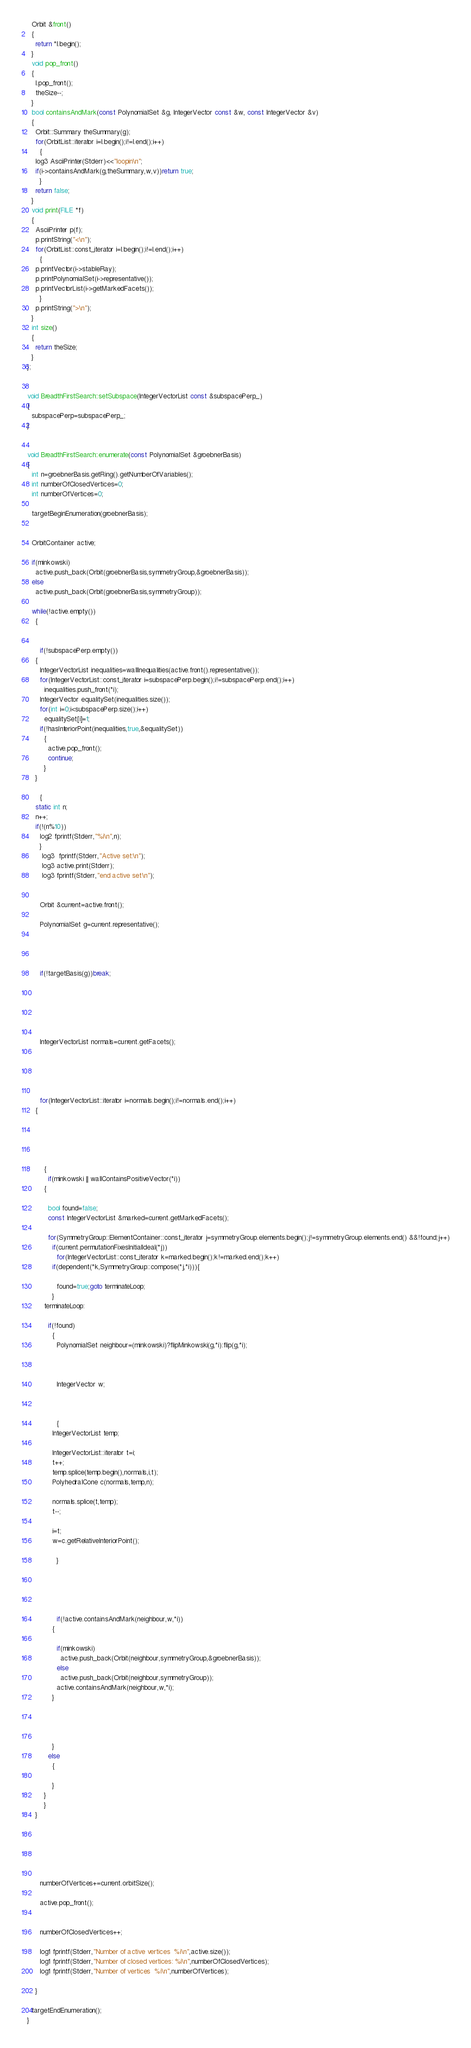<code> <loc_0><loc_0><loc_500><loc_500><_C++_>  Orbit &front()
  {
    return *l.begin();
  }
  void pop_front()
  {
    l.pop_front();
    theSize--;
  }
  bool containsAndMark(const PolynomialSet &g, IntegerVector const &w, const IntegerVector &v)
  {
    Orbit::Summary theSummary(g);
    for(OrbitList::iterator i=l.begin();i!=l.end();i++)
      {
	log3 AsciiPrinter(Stderr)<<"loopin\n";
	if(i->containsAndMark(g,theSummary,w,v))return true;
      }
    return false;
  }
  void print(FILE *f)
  {
    AsciiPrinter p(f);
    p.printString("<\n");
    for(OrbitList::const_iterator i=l.begin();i!=l.end();i++)
      {
	p.printVector(i->stableRay);
	p.printPolynomialSet(i->representative());
	p.printVectorList(i->getMarkedFacets());
      }
    p.printString(">\n");
  }
  int size()
  {    
    return theSize;
  }
};


void BreadthFirstSearch::setSubspace(IntegerVectorList const &subspacePerp_)
{
  subspacePerp=subspacePerp_;
}


void BreadthFirstSearch::enumerate(const PolynomialSet &groebnerBasis)
{
  int n=groebnerBasis.getRing().getNumberOfVariables();
  int numberOfClosedVertices=0;
  int numberOfVertices=0;

  targetBeginEnumeration(groebnerBasis);


  OrbitContainer active;

  if(minkowski)
    active.push_back(Orbit(groebnerBasis,symmetryGroup,&groebnerBasis));
  else
    active.push_back(Orbit(groebnerBasis,symmetryGroup));
    
  while(!active.empty())
    {
   

      if(!subspacePerp.empty())
	{
	  IntegerVectorList inequalities=wallInequalities(active.front().representative());
	  for(IntegerVectorList::const_iterator i=subspacePerp.begin();i!=subspacePerp.end();i++)
	    inequalities.push_front(*i);
	  IntegerVector equalitySet(inequalities.size());
	  for(int i=0;i<subspacePerp.size();i++)
	    equalitySet[i]=1;
	  if(!hasInteriorPoint(inequalities,true,&equalitySet))
	    {
	      active.pop_front();
	      continue;
	    }
	}

      {
	static int n;
	n++;
	if(!(n%10))
	  log2 fprintf(Stderr,"%i\n",n);
      }
       log3  fprintf(Stderr,"Active set:\n");
       log3 active.print(Stderr);
       log3 fprintf(Stderr,"end active set\n");
       
      
      Orbit &current=active.front();

      PolynomialSet g=current.representative();

      
      

      if(!targetBasis(g))break;

      
      

      
      
      IntegerVectorList normals=current.getFacets();

      

      

      for(IntegerVectorList::iterator i=normals.begin();i!=normals.end();i++)
	{
	  
	  
	  

	    
	    {
	      if(minkowski || wallContainsPositiveVector(*i))
		{
		  
		  bool found=false;
		  const IntegerVectorList &marked=current.getMarkedFacets();
		  
		  for(SymmetryGroup::ElementContainer::const_iterator j=symmetryGroup.elements.begin();j!=symmetryGroup.elements.end() &&!found;j++)
		    if(current.permutationFixesInitialIdeal(*j))
		      for(IntegerVectorList::const_iterator k=marked.begin();k!=marked.end();k++)
			if(dependent(*k,SymmetryGroup::compose(*j,*i))){
			  
			  found=true;goto terminateLoop;
			}
		terminateLoop:
		  
		  if(!found)
		    {
		      PolynomialSet neighbour=(minkowski)?flipMinkowski(g,*i):flip(g,*i);

		      
		      
		      IntegerVector w;

		      
		      
		      {
			IntegerVectorList temp;
			
			IntegerVectorList::iterator t=i;
			t++;
			temp.splice(temp.begin(),normals,i,t);
			PolyhedralCone c(normals,temp,n);
			
			normals.splice(t,temp);
			t--;
			
			i=t;
			w=c.getRelativeInteriorPoint();

		      }
		      
		      
		      


		      if(!active.containsAndMark(neighbour,w,*i))
			{
			  
			  if(minkowski)
			    active.push_back(Orbit(neighbour,symmetryGroup,&groebnerBasis));
			  else
			    active.push_back(Orbit(neighbour,symmetryGroup));
			  active.containsAndMark(neighbour,w,*i);
			}
		      
			
		      

		    }
		  else
		    {
		      
		    }
		}
	    }
	}
      
      
      

      

      numberOfVertices+=current.orbitSize();

      active.pop_front();  
      

      numberOfClosedVertices++;

      log1 fprintf(Stderr,"Number of active vertices  %i\n",active.size());
      log1 fprintf(Stderr,"Number of closed vertices: %i\n",numberOfClosedVertices);
      log1 fprintf(Stderr,"Number of vertices  %i\n",numberOfVertices);

    }

  targetEndEnumeration();
}
</code> 